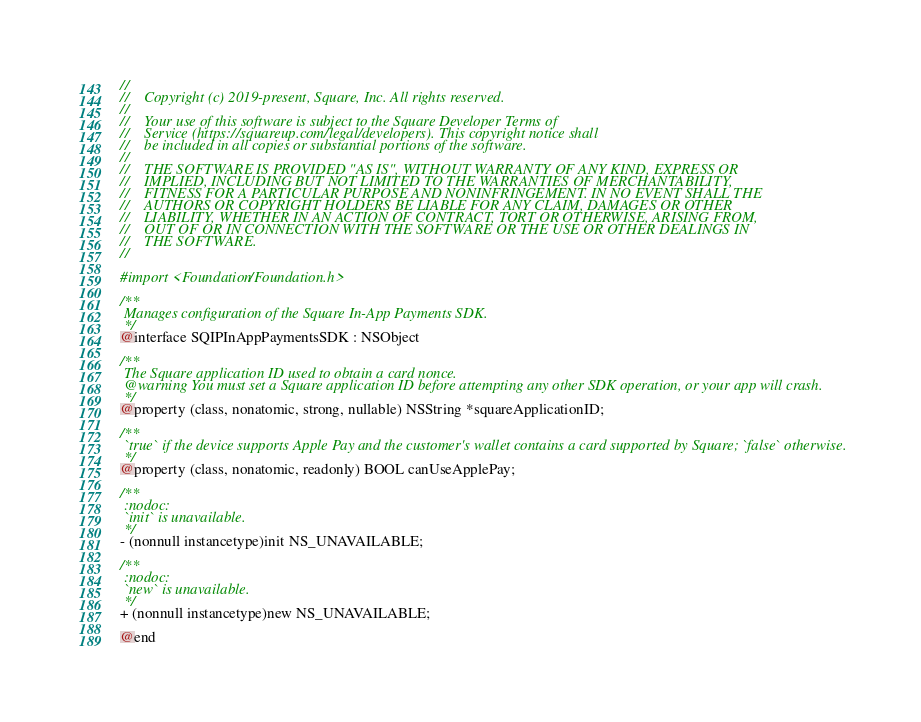<code> <loc_0><loc_0><loc_500><loc_500><_C_>//
//    Copyright (c) 2019-present, Square, Inc. All rights reserved.
//
//    Your use of this software is subject to the Square Developer Terms of
//    Service (https://squareup.com/legal/developers). This copyright notice shall
//    be included in all copies or substantial portions of the software.
//
//    THE SOFTWARE IS PROVIDED "AS IS", WITHOUT WARRANTY OF ANY KIND, EXPRESS OR
//    IMPLIED, INCLUDING BUT NOT LIMITED TO THE WARRANTIES OF MERCHANTABILITY,
//    FITNESS FOR A PARTICULAR PURPOSE AND NONINFRINGEMENT. IN NO EVENT SHALL THE
//    AUTHORS OR COPYRIGHT HOLDERS BE LIABLE FOR ANY CLAIM, DAMAGES OR OTHER
//    LIABILITY, WHETHER IN AN ACTION OF CONTRACT, TORT OR OTHERWISE, ARISING FROM,
//    OUT OF OR IN CONNECTION WITH THE SOFTWARE OR THE USE OR OTHER DEALINGS IN
//    THE SOFTWARE.
//

#import <Foundation/Foundation.h>

/**
 Manages configuration of the Square In-App Payments SDK.
 */
@interface SQIPInAppPaymentsSDK : NSObject

/**
 The Square application ID used to obtain a card nonce.
 @warning You must set a Square application ID before attempting any other SDK operation, or your app will crash.
 */
@property (class, nonatomic, strong, nullable) NSString *squareApplicationID;

/**
 `true` if the device supports Apple Pay and the customer's wallet contains a card supported by Square; `false` otherwise.
 */
@property (class, nonatomic, readonly) BOOL canUseApplePay;

/**
 :nodoc:
 `init` is unavailable.
 */
- (nonnull instancetype)init NS_UNAVAILABLE;

/**
 :nodoc:
 `new` is unavailable.
 */
+ (nonnull instancetype)new NS_UNAVAILABLE;

@end
</code> 